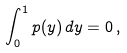Convert formula to latex. <formula><loc_0><loc_0><loc_500><loc_500>\int _ { 0 } ^ { 1 } p ( y ) \, d y = 0 \, ,</formula> 